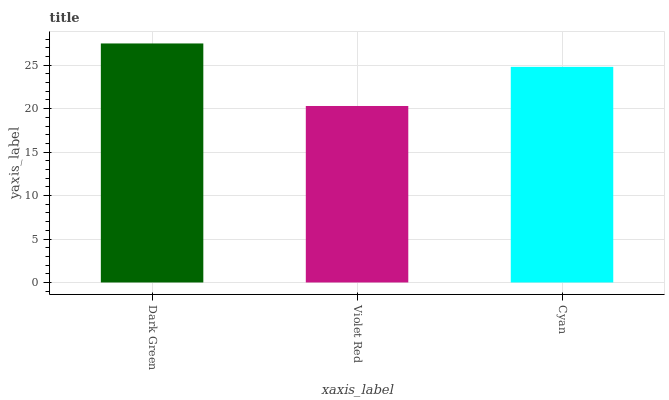Is Violet Red the minimum?
Answer yes or no. Yes. Is Dark Green the maximum?
Answer yes or no. Yes. Is Cyan the minimum?
Answer yes or no. No. Is Cyan the maximum?
Answer yes or no. No. Is Cyan greater than Violet Red?
Answer yes or no. Yes. Is Violet Red less than Cyan?
Answer yes or no. Yes. Is Violet Red greater than Cyan?
Answer yes or no. No. Is Cyan less than Violet Red?
Answer yes or no. No. Is Cyan the high median?
Answer yes or no. Yes. Is Cyan the low median?
Answer yes or no. Yes. Is Dark Green the high median?
Answer yes or no. No. Is Dark Green the low median?
Answer yes or no. No. 